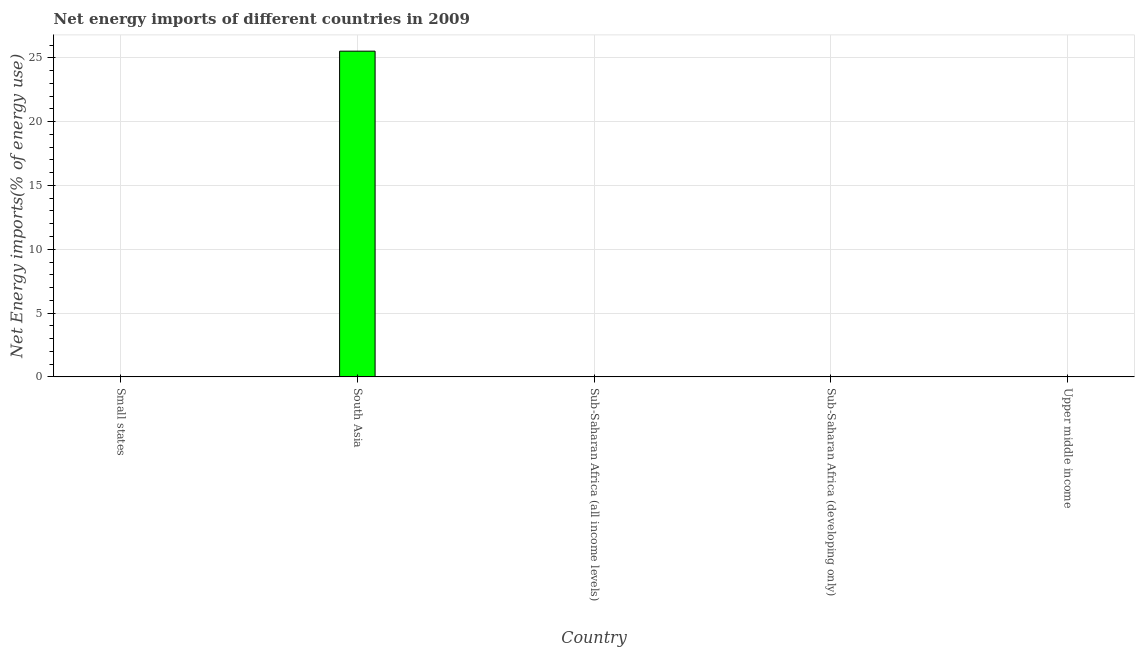What is the title of the graph?
Make the answer very short. Net energy imports of different countries in 2009. What is the label or title of the X-axis?
Keep it short and to the point. Country. What is the label or title of the Y-axis?
Make the answer very short. Net Energy imports(% of energy use). What is the energy imports in Sub-Saharan Africa (developing only)?
Keep it short and to the point. 0. Across all countries, what is the maximum energy imports?
Your answer should be very brief. 25.52. What is the sum of the energy imports?
Provide a short and direct response. 25.52. What is the average energy imports per country?
Your answer should be compact. 5.1. What is the median energy imports?
Ensure brevity in your answer.  0. In how many countries, is the energy imports greater than 13 %?
Your answer should be compact. 1. What is the difference between the highest and the lowest energy imports?
Your response must be concise. 25.52. How many bars are there?
Offer a very short reply. 1. Are all the bars in the graph horizontal?
Your response must be concise. No. What is the difference between two consecutive major ticks on the Y-axis?
Your answer should be very brief. 5. What is the Net Energy imports(% of energy use) in Small states?
Provide a succinct answer. 0. What is the Net Energy imports(% of energy use) in South Asia?
Your answer should be compact. 25.52. 